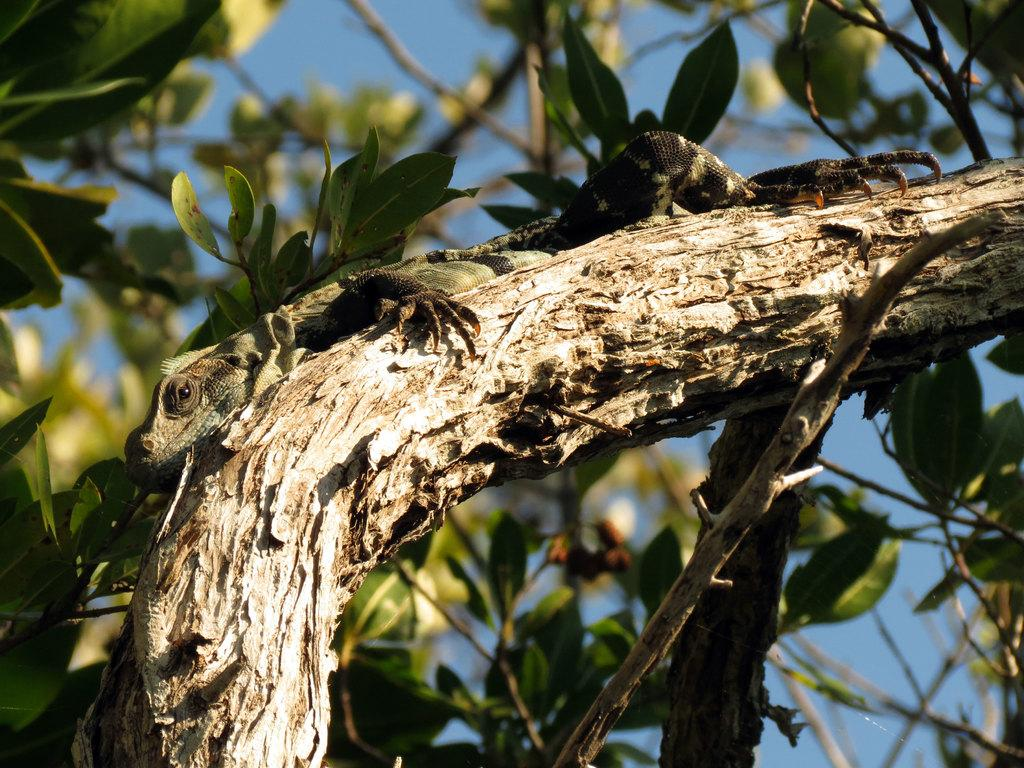What animal is present in the image? There is a chameleon in the image. Where is the chameleon located? The chameleon is on a tree branch. What can be seen in the background of the image? There are leaves, stems, and the sky visible in the background of the image. What type of shop can be seen in the background of the image? There is no shop present in the image; it features a chameleon on a tree branch with leaves, stems, and the sky visible in the background. 